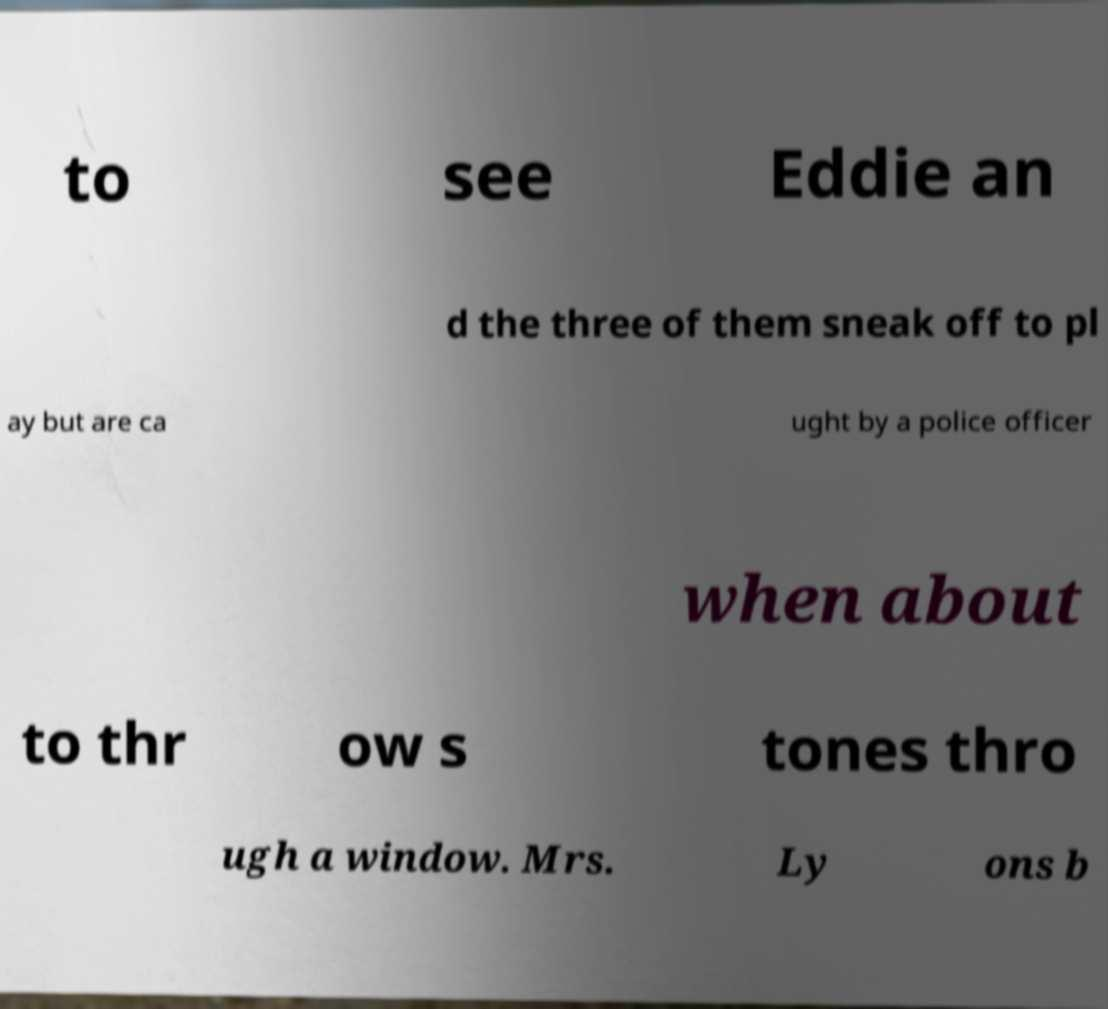There's text embedded in this image that I need extracted. Can you transcribe it verbatim? to see Eddie an d the three of them sneak off to pl ay but are ca ught by a police officer when about to thr ow s tones thro ugh a window. Mrs. Ly ons b 